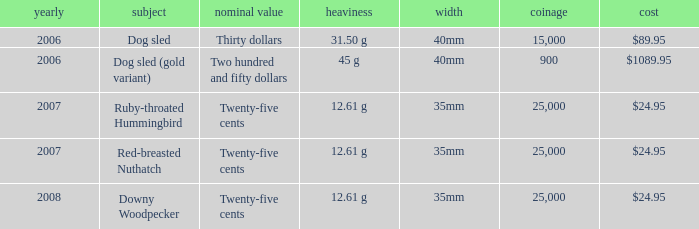Could you help me parse every detail presented in this table? {'header': ['yearly', 'subject', 'nominal value', 'heaviness', 'width', 'coinage', 'cost'], 'rows': [['2006', 'Dog sled', 'Thirty dollars', '31.50 g', '40mm', '15,000', '$89.95'], ['2006', 'Dog sled (gold variant)', 'Two hundred and fifty dollars', '45 g', '40mm', '900', '$1089.95'], ['2007', 'Ruby-throated Hummingbird', 'Twenty-five cents', '12.61 g', '35mm', '25,000', '$24.95'], ['2007', 'Red-breasted Nuthatch', 'Twenty-five cents', '12.61 g', '35mm', '25,000', '$24.95'], ['2008', 'Downy Woodpecker', 'Twenty-five cents', '12.61 g', '35mm', '25,000', '$24.95']]} What is the Theme of the coin with an Issue Price of $89.95? Dog sled. 